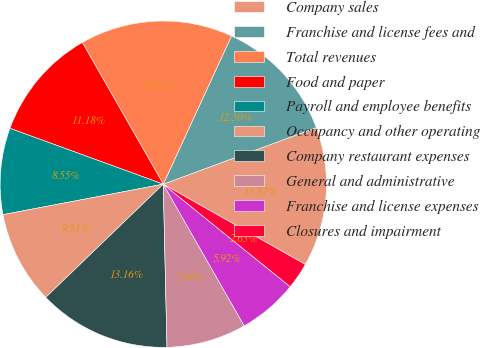Convert chart to OTSL. <chart><loc_0><loc_0><loc_500><loc_500><pie_chart><fcel>Company sales<fcel>Franchise and license fees and<fcel>Total revenues<fcel>Food and paper<fcel>Payroll and employee benefits<fcel>Occupancy and other operating<fcel>Company restaurant expenses<fcel>General and administrative<fcel>Franchise and license expenses<fcel>Closures and impairment<nl><fcel>13.82%<fcel>12.5%<fcel>15.13%<fcel>11.18%<fcel>8.55%<fcel>9.21%<fcel>13.16%<fcel>7.9%<fcel>5.92%<fcel>2.63%<nl></chart> 